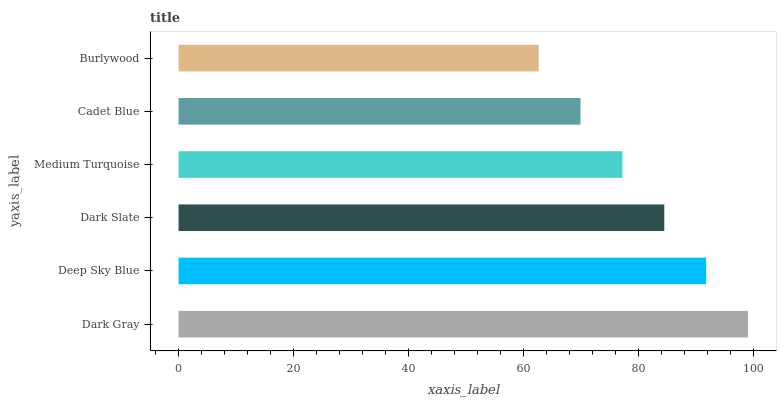Is Burlywood the minimum?
Answer yes or no. Yes. Is Dark Gray the maximum?
Answer yes or no. Yes. Is Deep Sky Blue the minimum?
Answer yes or no. No. Is Deep Sky Blue the maximum?
Answer yes or no. No. Is Dark Gray greater than Deep Sky Blue?
Answer yes or no. Yes. Is Deep Sky Blue less than Dark Gray?
Answer yes or no. Yes. Is Deep Sky Blue greater than Dark Gray?
Answer yes or no. No. Is Dark Gray less than Deep Sky Blue?
Answer yes or no. No. Is Dark Slate the high median?
Answer yes or no. Yes. Is Medium Turquoise the low median?
Answer yes or no. Yes. Is Cadet Blue the high median?
Answer yes or no. No. Is Dark Gray the low median?
Answer yes or no. No. 